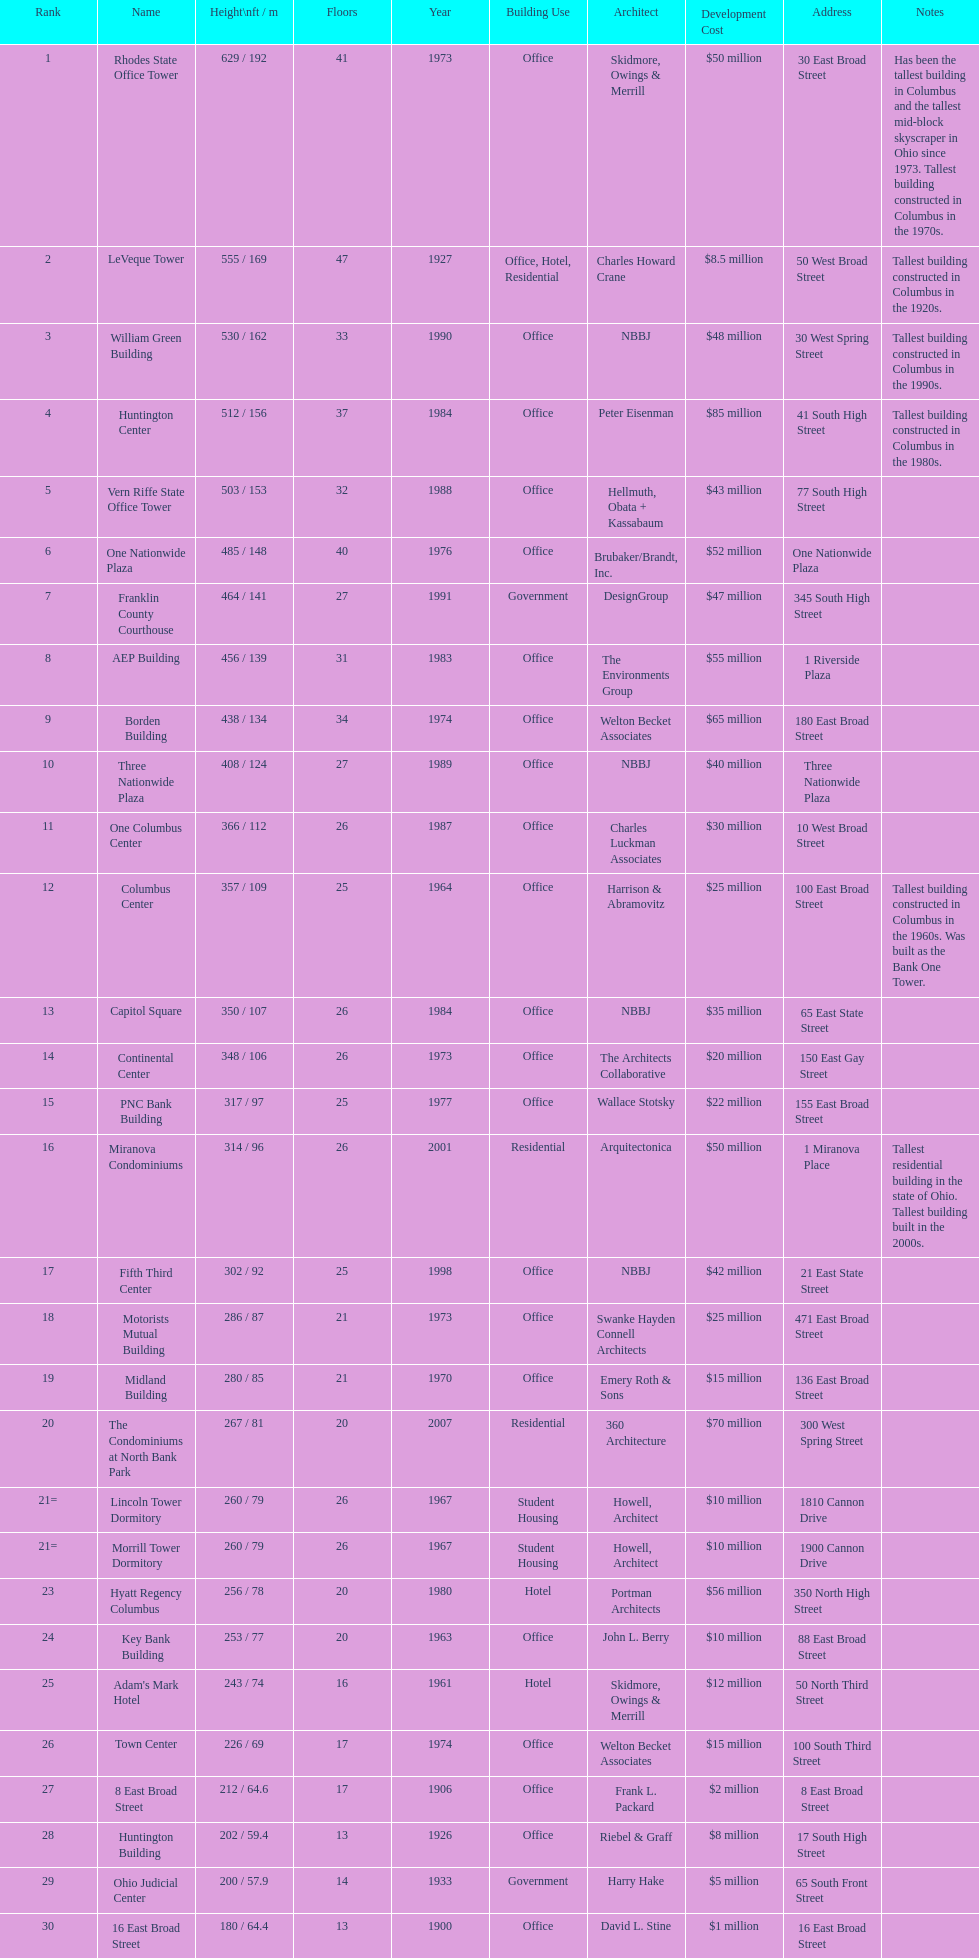How many floors does the capitol square have? 26. 